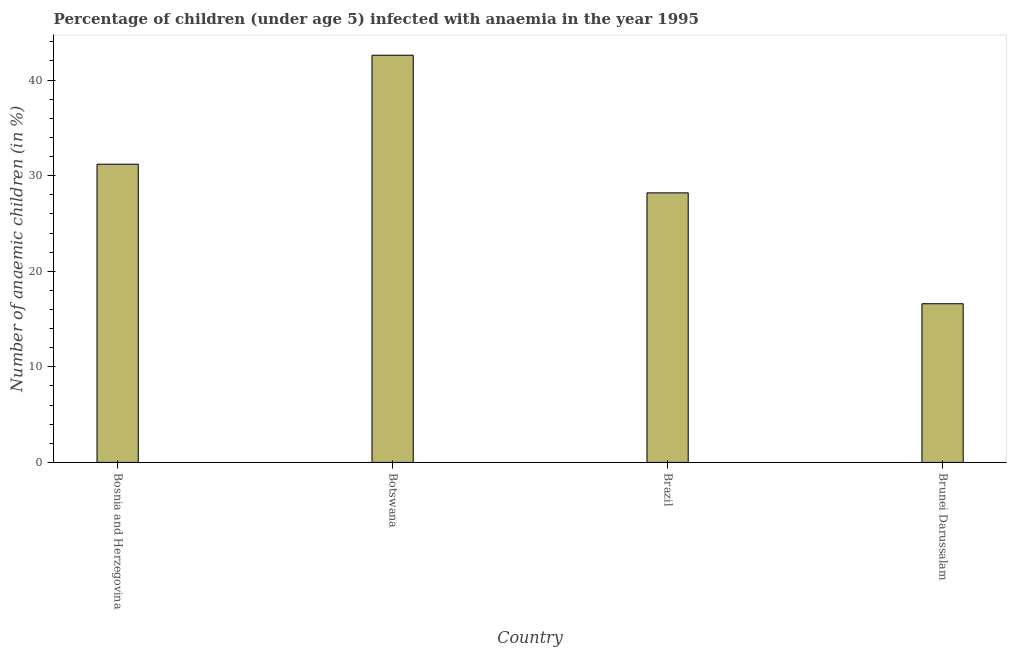Does the graph contain any zero values?
Provide a succinct answer. No. What is the title of the graph?
Provide a short and direct response. Percentage of children (under age 5) infected with anaemia in the year 1995. What is the label or title of the Y-axis?
Make the answer very short. Number of anaemic children (in %). Across all countries, what is the maximum number of anaemic children?
Your answer should be compact. 42.6. In which country was the number of anaemic children maximum?
Ensure brevity in your answer.  Botswana. In which country was the number of anaemic children minimum?
Make the answer very short. Brunei Darussalam. What is the sum of the number of anaemic children?
Offer a terse response. 118.6. What is the difference between the number of anaemic children in Bosnia and Herzegovina and Brunei Darussalam?
Your answer should be very brief. 14.6. What is the average number of anaemic children per country?
Make the answer very short. 29.65. What is the median number of anaemic children?
Your answer should be compact. 29.7. What is the ratio of the number of anaemic children in Botswana to that in Brazil?
Give a very brief answer. 1.51. What is the difference between the highest and the second highest number of anaemic children?
Ensure brevity in your answer.  11.4. Is the sum of the number of anaemic children in Botswana and Brunei Darussalam greater than the maximum number of anaemic children across all countries?
Offer a very short reply. Yes. How many countries are there in the graph?
Ensure brevity in your answer.  4. What is the difference between two consecutive major ticks on the Y-axis?
Provide a succinct answer. 10. What is the Number of anaemic children (in %) in Bosnia and Herzegovina?
Offer a terse response. 31.2. What is the Number of anaemic children (in %) in Botswana?
Keep it short and to the point. 42.6. What is the Number of anaemic children (in %) of Brazil?
Provide a short and direct response. 28.2. What is the Number of anaemic children (in %) in Brunei Darussalam?
Provide a succinct answer. 16.6. What is the difference between the Number of anaemic children (in %) in Bosnia and Herzegovina and Botswana?
Ensure brevity in your answer.  -11.4. What is the difference between the Number of anaemic children (in %) in Bosnia and Herzegovina and Brunei Darussalam?
Ensure brevity in your answer.  14.6. What is the difference between the Number of anaemic children (in %) in Botswana and Brazil?
Your answer should be very brief. 14.4. What is the ratio of the Number of anaemic children (in %) in Bosnia and Herzegovina to that in Botswana?
Provide a succinct answer. 0.73. What is the ratio of the Number of anaemic children (in %) in Bosnia and Herzegovina to that in Brazil?
Offer a very short reply. 1.11. What is the ratio of the Number of anaemic children (in %) in Bosnia and Herzegovina to that in Brunei Darussalam?
Your response must be concise. 1.88. What is the ratio of the Number of anaemic children (in %) in Botswana to that in Brazil?
Keep it short and to the point. 1.51. What is the ratio of the Number of anaemic children (in %) in Botswana to that in Brunei Darussalam?
Your response must be concise. 2.57. What is the ratio of the Number of anaemic children (in %) in Brazil to that in Brunei Darussalam?
Offer a terse response. 1.7. 